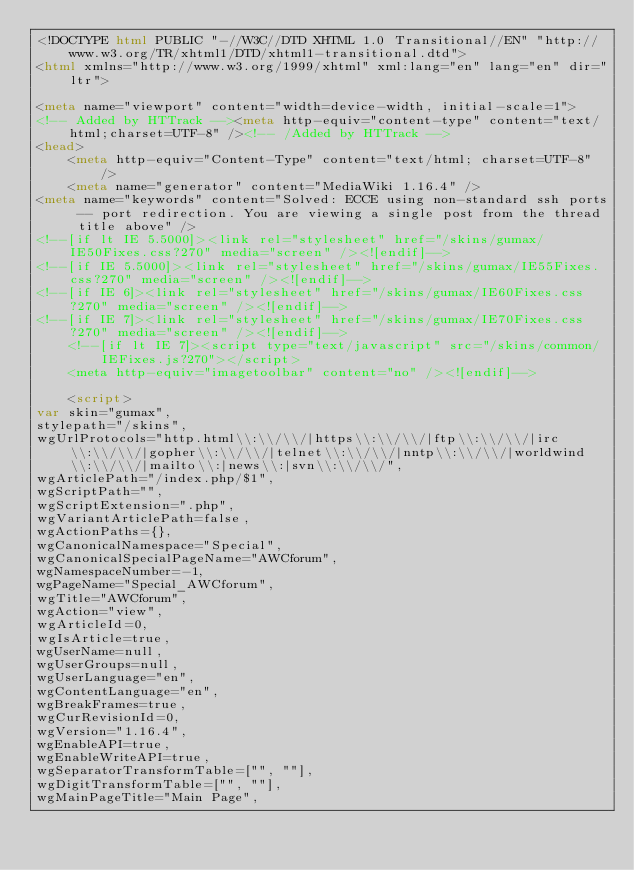<code> <loc_0><loc_0><loc_500><loc_500><_HTML_><!DOCTYPE html PUBLIC "-//W3C//DTD XHTML 1.0 Transitional//EN" "http://www.w3.org/TR/xhtml1/DTD/xhtml1-transitional.dtd">
<html xmlns="http://www.w3.org/1999/xhtml" xml:lang="en" lang="en" dir="ltr">
	
<meta name="viewport" content="width=device-width, initial-scale=1">
<!-- Added by HTTrack --><meta http-equiv="content-type" content="text/html;charset=UTF-8" /><!-- /Added by HTTrack -->
<head>
		<meta http-equiv="Content-Type" content="text/html; charset=UTF-8" />
		<meta name="generator" content="MediaWiki 1.16.4" />
<meta name="keywords" content="Solved: ECCE using non-standard ssh ports -- port redirection. You are viewing a single post from the thread title above" />
<!--[if lt IE 5.5000]><link rel="stylesheet" href="/skins/gumax/IE50Fixes.css?270" media="screen" /><![endif]-->
<!--[if IE 5.5000]><link rel="stylesheet" href="/skins/gumax/IE55Fixes.css?270" media="screen" /><![endif]-->
<!--[if IE 6]><link rel="stylesheet" href="/skins/gumax/IE60Fixes.css?270" media="screen" /><![endif]-->
<!--[if IE 7]><link rel="stylesheet" href="/skins/gumax/IE70Fixes.css?270" media="screen" /><![endif]-->
		<!--[if lt IE 7]><script type="text/javascript" src="/skins/common/IEFixes.js?270"></script>
		<meta http-equiv="imagetoolbar" content="no" /><![endif]-->

		<script>
var skin="gumax",
stylepath="/skins",
wgUrlProtocols="http.html\\:\\/\\/|https\\:\\/\\/|ftp\\:\\/\\/|irc\\:\\/\\/|gopher\\:\\/\\/|telnet\\:\\/\\/|nntp\\:\\/\\/|worldwind\\:\\/\\/|mailto\\:|news\\:|svn\\:\\/\\/",
wgArticlePath="/index.php/$1",
wgScriptPath="",
wgScriptExtension=".php",
wgVariantArticlePath=false,
wgActionPaths={},
wgCanonicalNamespace="Special",
wgCanonicalSpecialPageName="AWCforum",
wgNamespaceNumber=-1,
wgPageName="Special_AWCforum",
wgTitle="AWCforum",
wgAction="view",
wgArticleId=0,
wgIsArticle=true,
wgUserName=null,
wgUserGroups=null,
wgUserLanguage="en",
wgContentLanguage="en",
wgBreakFrames=true,
wgCurRevisionId=0,
wgVersion="1.16.4",
wgEnableAPI=true,
wgEnableWriteAPI=true,
wgSeparatorTransformTable=["", ""],
wgDigitTransformTable=["", ""],
wgMainPageTitle="Main Page",</code> 